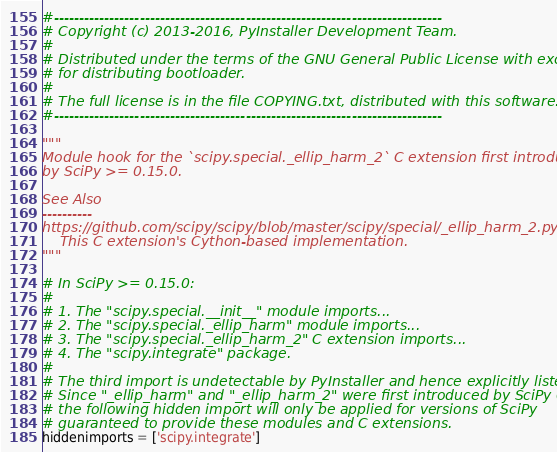<code> <loc_0><loc_0><loc_500><loc_500><_Python_>#-----------------------------------------------------------------------------
# Copyright (c) 2013-2016, PyInstaller Development Team.
#
# Distributed under the terms of the GNU General Public License with exception
# for distributing bootloader.
#
# The full license is in the file COPYING.txt, distributed with this software.
#-----------------------------------------------------------------------------

"""
Module hook for the `scipy.special._ellip_harm_2` C extension first introduced
by SciPy >= 0.15.0.

See Also
----------
https://github.com/scipy/scipy/blob/master/scipy/special/_ellip_harm_2.pyx
    This C extension's Cython-based implementation.
"""

# In SciPy >= 0.15.0:
#
# 1. The "scipy.special.__init__" module imports...
# 2. The "scipy.special._ellip_harm" module imports...
# 3. The "scipy.special._ellip_harm_2" C extension imports...
# 4. The "scipy.integrate" package.
#
# The third import is undetectable by PyInstaller and hence explicitly listed.
# Since "_ellip_harm" and "_ellip_harm_2" were first introduced by SciPy 0.15.0,
# the following hidden import will only be applied for versions of SciPy
# guaranteed to provide these modules and C extensions.
hiddenimports = ['scipy.integrate']
</code> 